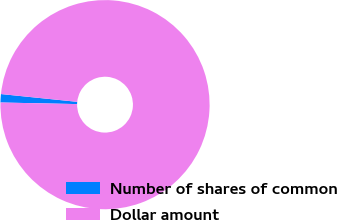Convert chart to OTSL. <chart><loc_0><loc_0><loc_500><loc_500><pie_chart><fcel>Number of shares of common<fcel>Dollar amount<nl><fcel>1.29%<fcel>98.71%<nl></chart> 